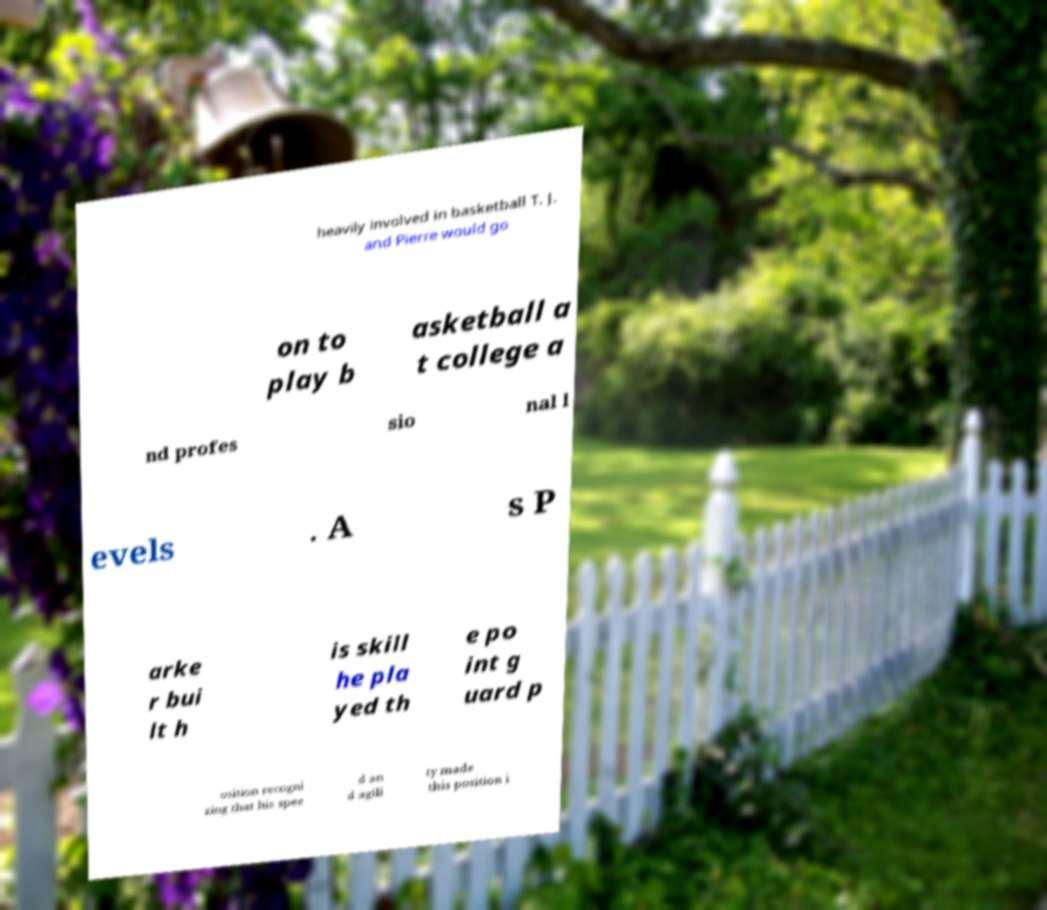Could you extract and type out the text from this image? heavily involved in basketball T. J. and Pierre would go on to play b asketball a t college a nd profes sio nal l evels . A s P arke r bui lt h is skill he pla yed th e po int g uard p osition recogni zing that his spee d an d agili ty made this position i 